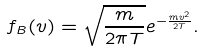<formula> <loc_0><loc_0><loc_500><loc_500>f _ { B } ( v ) = \sqrt { \frac { m } { 2 \pi T } } e ^ { - \frac { m v ^ { 2 } } { 2 T } } .</formula> 